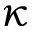<formula> <loc_0><loc_0><loc_500><loc_500>\kappa</formula> 